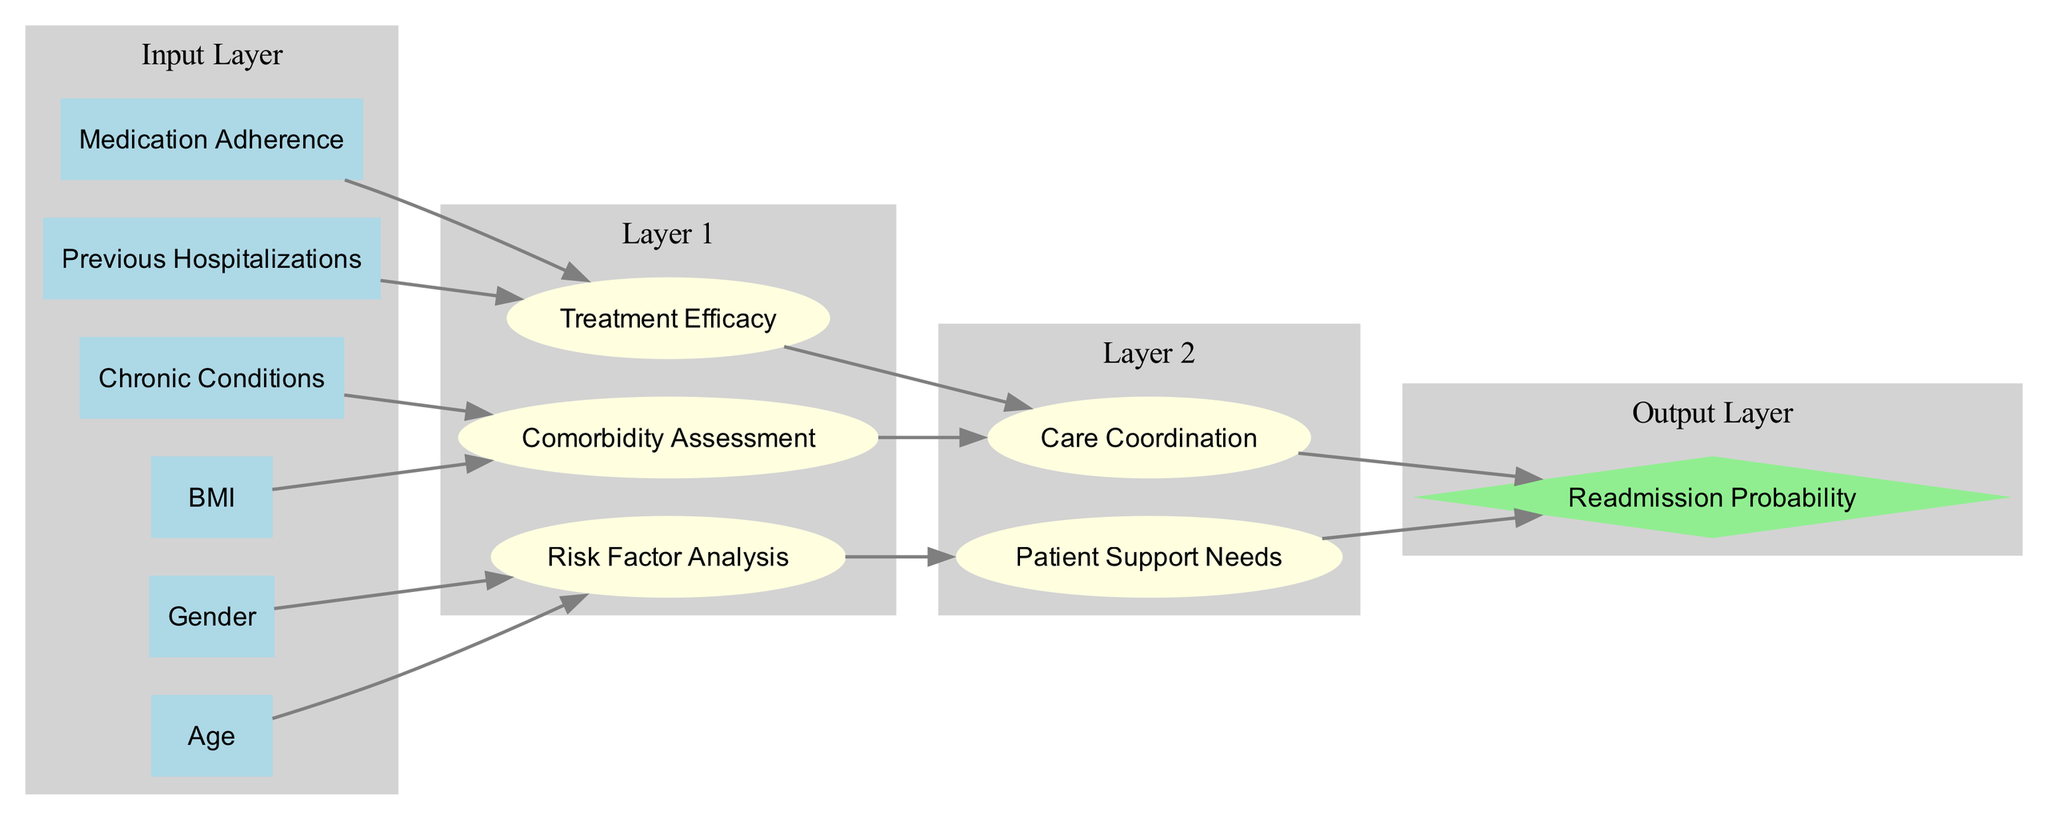What is the output node of the neural network? The output node is specified in the data as "Readmission Probability." It is the final node that receives inputs from the hidden layers.
Answer: Readmission Probability How many input nodes are present in the diagram? The input nodes listed are six: Age, Gender, BMI, Previous Hospitalizations, Chronic Conditions, and Medication Adherence, making a total of six input nodes.
Answer: Six Which input node connects to the "Comorbidity Assessment" node? The nodes that provide input to "Comorbidity Assessment" are "BMI" and "Chronic Conditions." Both these input nodes link directly to this hidden layer node.
Answer: BMI, Chronic Conditions How many hidden layers are there in this diagram? The diagram contains two hidden layers, as defined in the data. Each layer has distinct nodes contributing to the output.
Answer: Two What is the direct connection from "Risk Factor Analysis"? The "Risk Factor Analysis" node connects directly to "Patient Support Needs." This connection indicates a flow of information contributing to patient support.
Answer: Patient Support Needs Which nodes connect to the output node "Readmission Probability"? The output node "Readmission Probability" has direct connections from "Patient Support Needs" and "Care Coordination." Both nodes influence the final prediction of readmission rates.
Answer: Patient Support Needs, Care Coordination What role does "Previous Hospitalizations" play in the diagram? The "Previous Hospitalizations" node connects to the "Treatment Efficacy" hidden layer node, contributing to the assessment of how past hospitalizations impact treatment effectiveness.
Answer: Treatment Efficacy What color is used for the output layer in the diagram? The output layer is represented in a light green color, which is a distinct choice to highlight the final prediction node, differentiating it from other layers.
Answer: Light green Which layer assesses "Care Coordination"? "Care Coordination" is assessed in "Layer 2," which is the second hidden layer of the network. This layer focuses on the aspects of coordination needed for patient care based on inputs from earlier layers.
Answer: Layer 2 